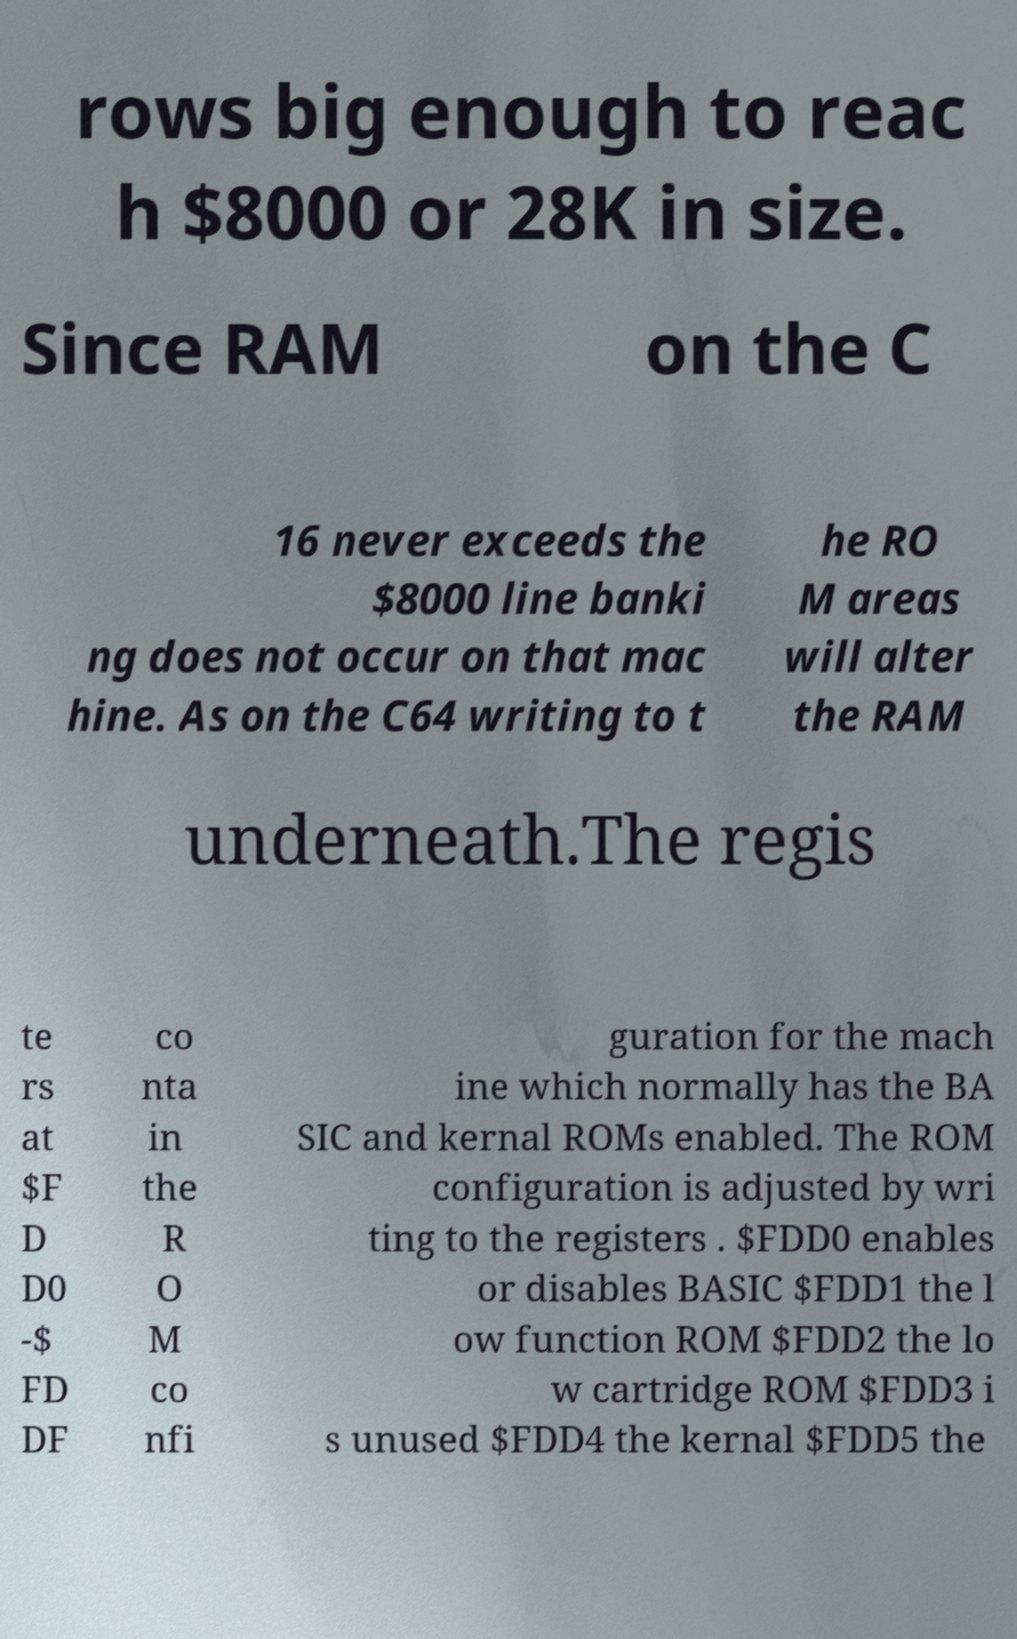Could you extract and type out the text from this image? rows big enough to reac h $8000 or 28K in size. Since RAM on the C 16 never exceeds the $8000 line banki ng does not occur on that mac hine. As on the C64 writing to t he RO M areas will alter the RAM underneath.The regis te rs at $F D D0 -$ FD DF co nta in the R O M co nfi guration for the mach ine which normally has the BA SIC and kernal ROMs enabled. The ROM configuration is adjusted by wri ting to the registers . $FDD0 enables or disables BASIC $FDD1 the l ow function ROM $FDD2 the lo w cartridge ROM $FDD3 i s unused $FDD4 the kernal $FDD5 the 